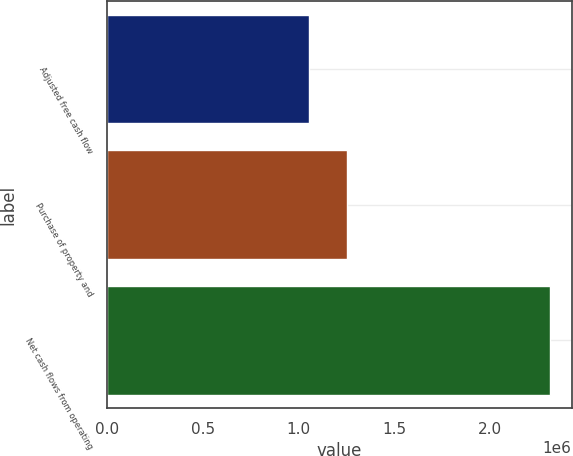<chart> <loc_0><loc_0><loc_500><loc_500><bar_chart><fcel>Adjusted free cash flow<fcel>Purchase of property and<fcel>Net cash flows from operating<nl><fcel>1.0557e+06<fcel>1.2535e+06<fcel>2.3092e+06<nl></chart> 